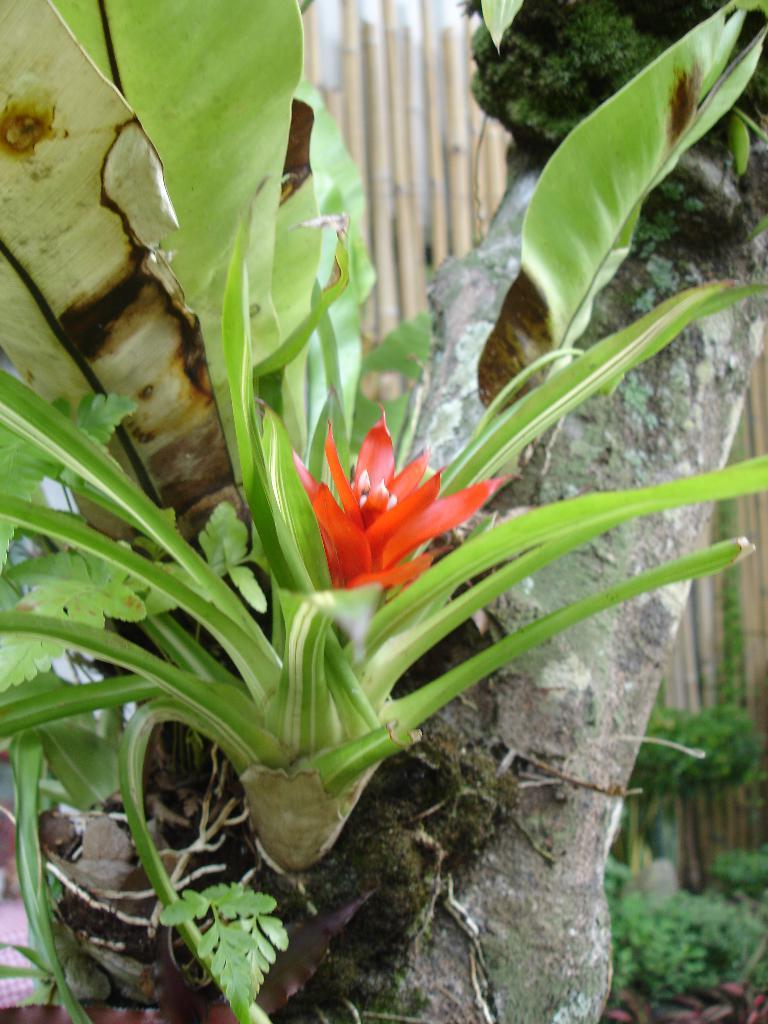What type of flower can be seen on a tree in the image? There is a red color flower on a tree in the image. How would you describe the background of the image? The background of the image is slightly blurred. What can be seen in the background of the image? There is a fence and plants visible in the background of the image. Can you tell me how many strangers are walking on the street in the image? There is no street or strangers present in the image; it features a tree with a red flower and a slightly blurred background. 